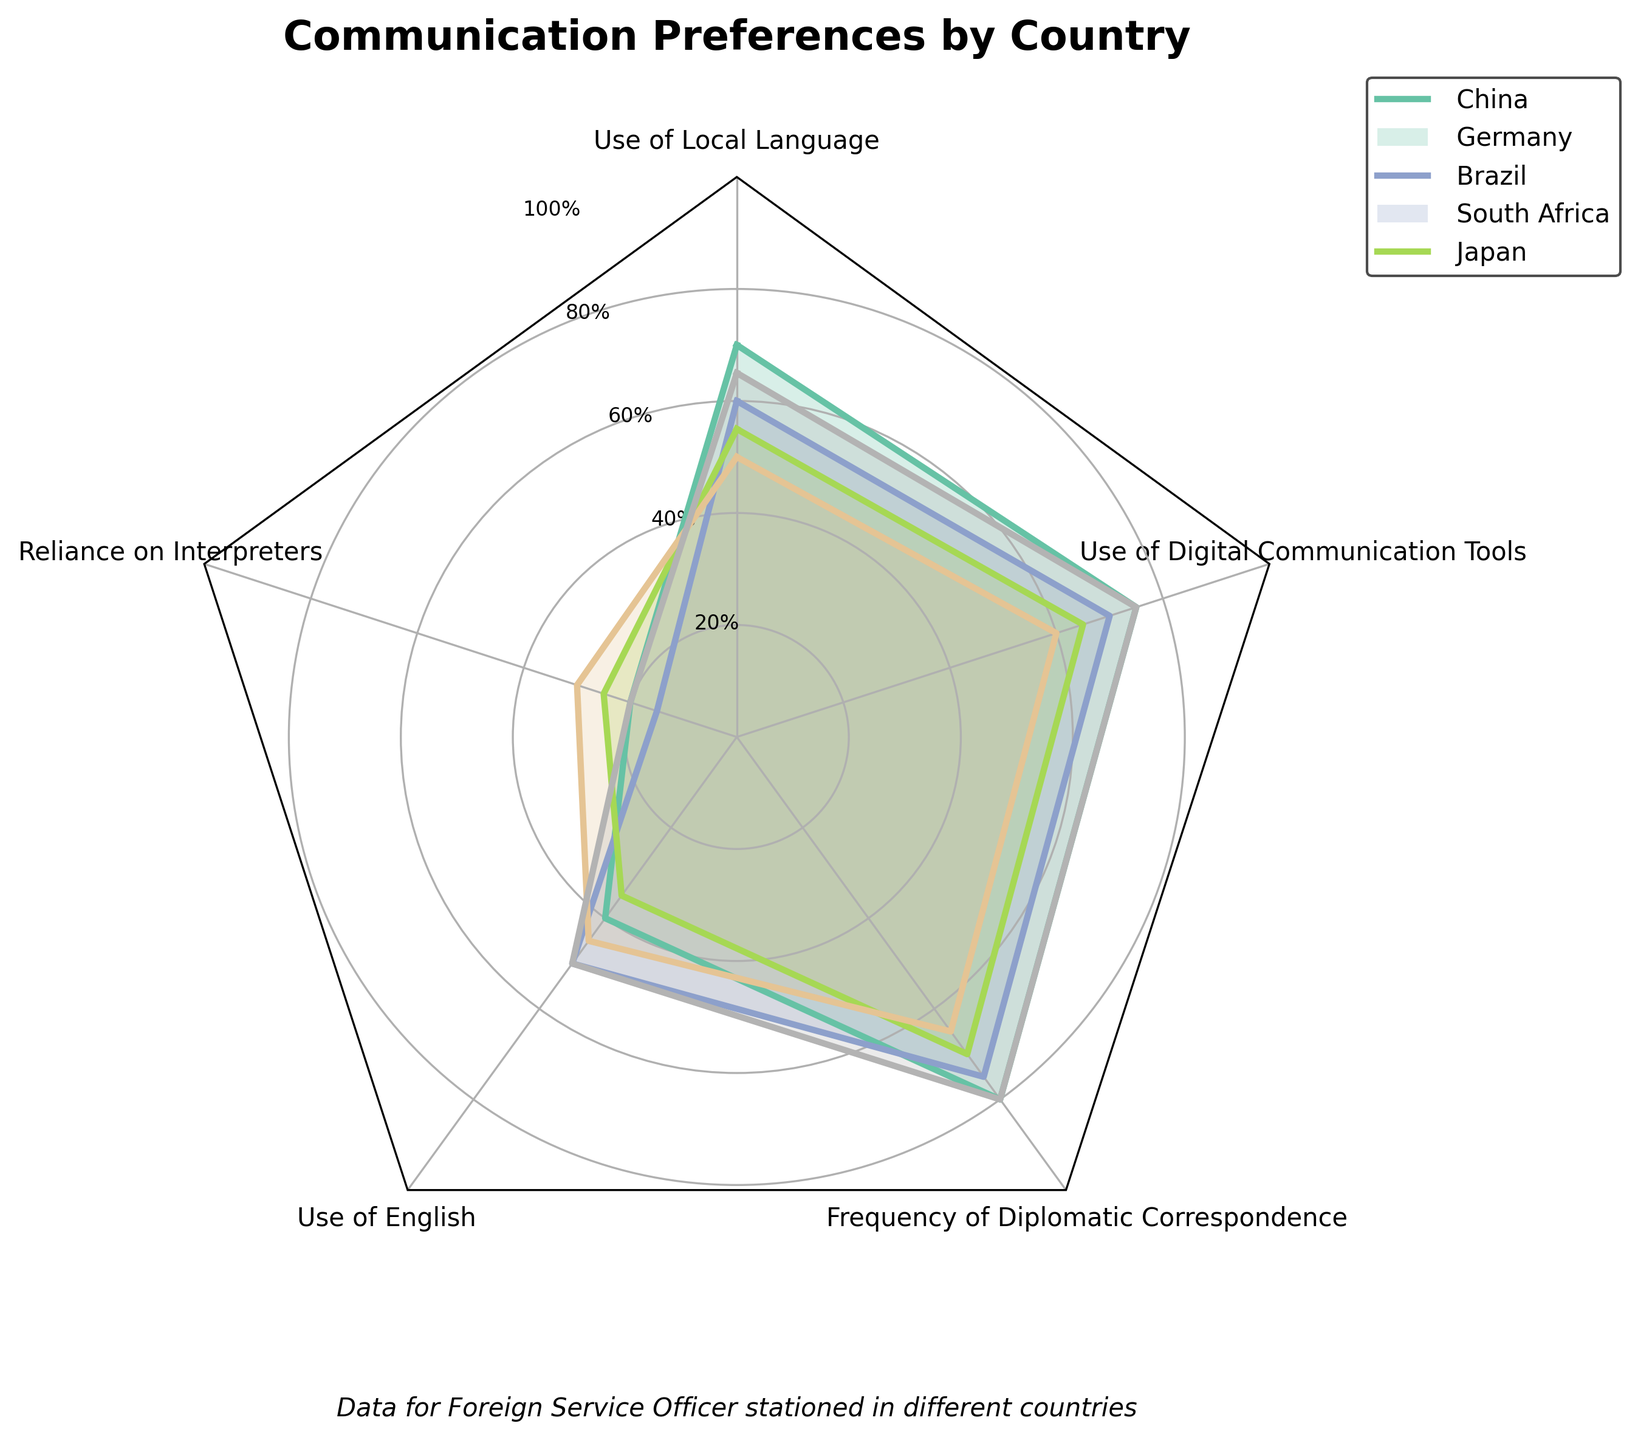what is the highest value for any category across all countries? To find the highest value for any category across all countries, look for the highest point on any axis of the radar chart. The highest value appears at the top of the axis for "Frequency of Diplomatic Correspondence" and "Use of Digital Communication Tools," both in China and Japan with a value of 80.
Answer: 80 Which country shows the highest use of local language? To find this, look at the axis for "Use of Local Language" and find the data point farthest away from the center. The highest value in this category is China with 70.
Answer: China Which category has the least variation across all countries? To determine the least varied category, you should look for the axis where the data points are closest together. "Use of English" displays a narrow range of values (40 to 50).
Answer: Use of English In which category does Brazil rely more than Germany? Compare the values for Brazil and Germany across all categories and find out where Brazil's value exceeds Germany's. In the category "Reliance on Interpreters," Brazil has 25, while Germany has 15.
Answer: Reliance on Interpreters Which country has the most balanced communication preferences across all categories? To figure out which country has the most balanced preferences, look for the country whose data points form a shape closest to a symmetrical polygon. South Africa's data points form a more balanced shape with no extreme values.
Answer: South Africa What is the average use of digital communication tools across all five countries? Calculate the average by summing the values for "Use of Digital Communication Tools" then dividing by the number of countries. The values are 75, 70, 65, 60, and 75. Sum these (75 + 70 + 65 + 60 + 75 = 345) and divide by 5 to get the average.
Answer: 69 Which country shows the greatest reliance on interpreters? To find out the greatest reliance on interpreters, identify the highest value on the "Reliance on Interpreters" axis. South Africa shows the highest value with 30.
Answer: South Africa How does the frequency of diplomatic correspondence in Brazil compare to that in Germany? On the radar chart, find the "Frequency of Diplomatic Correspondence" values for both Brazil and Germany. Brazil has a value of 70, whereas Germany has 75. Brazil's frequency is 5 units lower than Germany's.
Answer: Brazil's frequency is 5 units lower Which country has the highest combined score for "Use of Local Language" and "Use of Digital Communication Tools"? Sum the values for "Use of Local Language" and "Use of Digital Communication Tools" for each country. China has (70 + 75 = 145), Germany has (60 + 70 = 130), Brazil has (55 + 65 = 120), South Africa has (50 + 60 = 110), and Japan has (65 + 75 = 140). China has the highest combined score.
Answer: China 